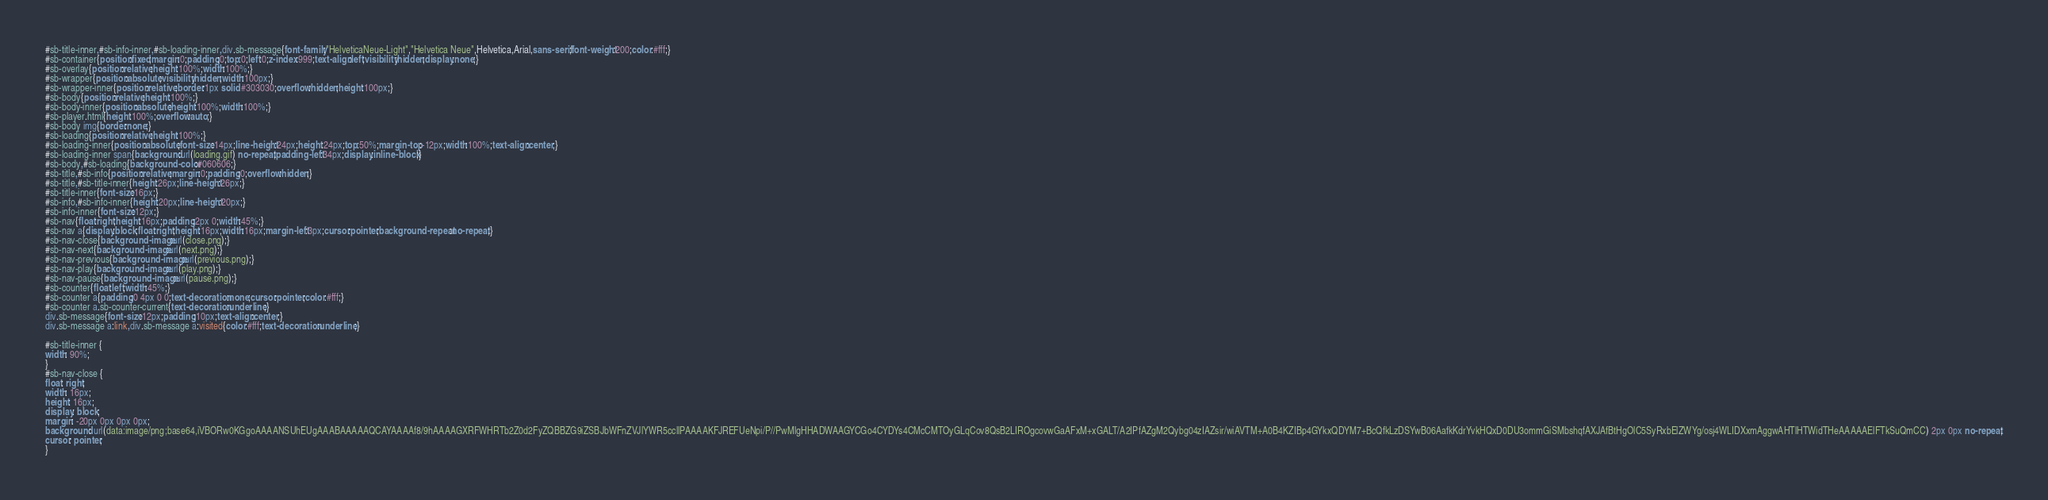<code> <loc_0><loc_0><loc_500><loc_500><_CSS_>#sb-title-inner,#sb-info-inner,#sb-loading-inner,div.sb-message{font-family:"HelveticaNeue-Light","Helvetica Neue",Helvetica,Arial,sans-serif;font-weight:200;color:#fff;}
#sb-container{position:fixed;margin:0;padding:0;top:0;left:0;z-index:999;text-align:left;visibility:hidden;display:none;}
#sb-overlay{position:relative;height:100%;width:100%;}
#sb-wrapper{position:absolute;visibility:hidden;width:100px;}
#sb-wrapper-inner{position:relative;border:1px solid #303030;overflow:hidden;height:100px;}
#sb-body{position:relative;height:100%;}
#sb-body-inner{position:absolute;height:100%;width:100%;}
#sb-player.html{height:100%;overflow:auto;}
#sb-body img{border:none;}
#sb-loading{position:relative;height:100%;}
#sb-loading-inner{position:absolute;font-size:14px;line-height:24px;height:24px;top:50%;margin-top:-12px;width:100%;text-align:center;}
#sb-loading-inner span{background:url(loading.gif) no-repeat;padding-left:34px;display:inline-block;}
#sb-body,#sb-loading{background-color:#060606;}
#sb-title,#sb-info{position:relative;margin:0;padding:0;overflow:hidden;}
#sb-title,#sb-title-inner{height:26px;line-height:26px;}
#sb-title-inner{font-size:16px;}
#sb-info,#sb-info-inner{height:20px;line-height:20px;}
#sb-info-inner{font-size:12px;}
#sb-nav{float:right;height:16px;padding:2px 0;width:45%;}
#sb-nav a{display:block;float:right;height:16px;width:16px;margin-left:3px;cursor:pointer;background-repeat:no-repeat;}
#sb-nav-close{background-image:url(close.png);}
#sb-nav-next{background-image:url(next.png);}
#sb-nav-previous{background-image:url(previous.png);}
#sb-nav-play{background-image:url(play.png);}
#sb-nav-pause{background-image:url(pause.png);}
#sb-counter{float:left;width:45%;}
#sb-counter a{padding:0 4px 0 0;text-decoration:none;cursor:pointer;color:#fff;}
#sb-counter a.sb-counter-current{text-decoration:underline;}
div.sb-message{font-size:12px;padding:10px;text-align:center;}
div.sb-message a:link,div.sb-message a:visited{color:#fff;text-decoration:underline;}

#sb-title-inner {
width: 90%;
}
#sb-nav-close {
float: right;
width: 16px;
height: 16px;
display: block;
margin: -20px 0px 0px 0px;
background: url(data:image/png;base64,iVBORw0KGgoAAAANSUhEUgAAABAAAAAQCAYAAAAf8/9hAAAAGXRFWHRTb2Z0d2FyZQBBZG9iZSBJbWFnZVJlYWR5ccllPAAAAKFJREFUeNpi/P//PwMlgHHADWAAGYCGo4CYDYs4CMcCMTOyGLqCov8QsB2LIROgcovwGaAFxM+xGALT/A2IPfAZgM2Qybg04zIAZsir/wiAVTM+A0B4KZIBp4GYkxQDYM7+BcQfkLzDSYwB06AafkKdrYvkHQxD0DU3ommGiSMbshqfAXJAfBtHgOlC5SyRxbElZWYg/osj4WLIDXxmAggwAHTlHTWidTHeAAAAAElFTkSuQmCC) 2px 0px no-repeat;
cursor: pointer;
}</code> 